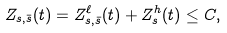<formula> <loc_0><loc_0><loc_500><loc_500>Z _ { s , \bar { s } } ( t ) = Z _ { s , \bar { s } } ^ { \ell } ( t ) + Z _ { s } ^ { h } ( t ) \leq C ,</formula> 